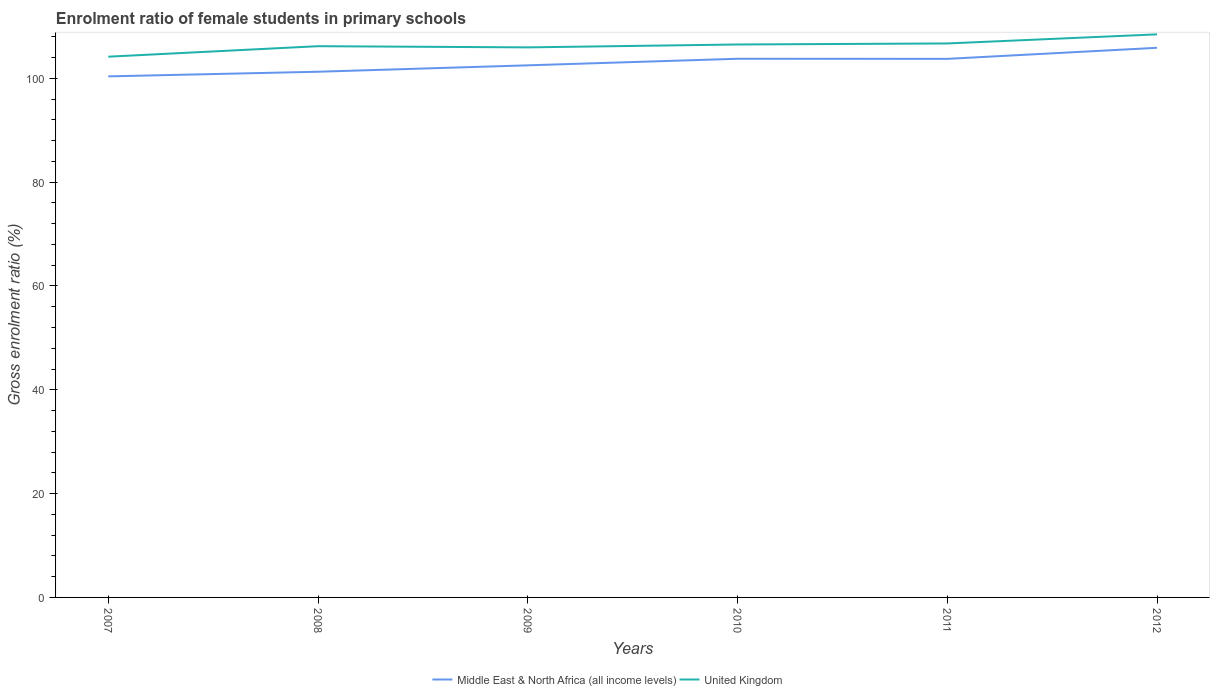How many different coloured lines are there?
Provide a succinct answer. 2. Does the line corresponding to United Kingdom intersect with the line corresponding to Middle East & North Africa (all income levels)?
Give a very brief answer. No. Is the number of lines equal to the number of legend labels?
Offer a terse response. Yes. Across all years, what is the maximum enrolment ratio of female students in primary schools in United Kingdom?
Offer a terse response. 104.18. In which year was the enrolment ratio of female students in primary schools in Middle East & North Africa (all income levels) maximum?
Make the answer very short. 2007. What is the total enrolment ratio of female students in primary schools in United Kingdom in the graph?
Your response must be concise. -2.28. What is the difference between the highest and the second highest enrolment ratio of female students in primary schools in United Kingdom?
Provide a short and direct response. 4.3. Is the enrolment ratio of female students in primary schools in United Kingdom strictly greater than the enrolment ratio of female students in primary schools in Middle East & North Africa (all income levels) over the years?
Your answer should be compact. No. How many years are there in the graph?
Your answer should be very brief. 6. What is the difference between two consecutive major ticks on the Y-axis?
Offer a very short reply. 20. Are the values on the major ticks of Y-axis written in scientific E-notation?
Offer a terse response. No. Does the graph contain any zero values?
Give a very brief answer. No. How are the legend labels stacked?
Your answer should be compact. Horizontal. What is the title of the graph?
Provide a short and direct response. Enrolment ratio of female students in primary schools. Does "Zimbabwe" appear as one of the legend labels in the graph?
Your answer should be very brief. No. What is the Gross enrolment ratio (%) in Middle East & North Africa (all income levels) in 2007?
Your answer should be very brief. 100.38. What is the Gross enrolment ratio (%) of United Kingdom in 2007?
Provide a succinct answer. 104.18. What is the Gross enrolment ratio (%) of Middle East & North Africa (all income levels) in 2008?
Offer a terse response. 101.28. What is the Gross enrolment ratio (%) of United Kingdom in 2008?
Make the answer very short. 106.2. What is the Gross enrolment ratio (%) in Middle East & North Africa (all income levels) in 2009?
Offer a terse response. 102.51. What is the Gross enrolment ratio (%) of United Kingdom in 2009?
Give a very brief answer. 105.97. What is the Gross enrolment ratio (%) in Middle East & North Africa (all income levels) in 2010?
Keep it short and to the point. 103.78. What is the Gross enrolment ratio (%) in United Kingdom in 2010?
Give a very brief answer. 106.53. What is the Gross enrolment ratio (%) in Middle East & North Africa (all income levels) in 2011?
Your response must be concise. 103.76. What is the Gross enrolment ratio (%) of United Kingdom in 2011?
Make the answer very short. 106.72. What is the Gross enrolment ratio (%) in Middle East & North Africa (all income levels) in 2012?
Make the answer very short. 105.89. What is the Gross enrolment ratio (%) of United Kingdom in 2012?
Offer a terse response. 108.48. Across all years, what is the maximum Gross enrolment ratio (%) of Middle East & North Africa (all income levels)?
Your answer should be compact. 105.89. Across all years, what is the maximum Gross enrolment ratio (%) in United Kingdom?
Make the answer very short. 108.48. Across all years, what is the minimum Gross enrolment ratio (%) of Middle East & North Africa (all income levels)?
Ensure brevity in your answer.  100.38. Across all years, what is the minimum Gross enrolment ratio (%) in United Kingdom?
Provide a succinct answer. 104.18. What is the total Gross enrolment ratio (%) in Middle East & North Africa (all income levels) in the graph?
Offer a very short reply. 617.59. What is the total Gross enrolment ratio (%) in United Kingdom in the graph?
Give a very brief answer. 638.07. What is the difference between the Gross enrolment ratio (%) in Middle East & North Africa (all income levels) in 2007 and that in 2008?
Provide a short and direct response. -0.89. What is the difference between the Gross enrolment ratio (%) of United Kingdom in 2007 and that in 2008?
Your answer should be compact. -2.02. What is the difference between the Gross enrolment ratio (%) in Middle East & North Africa (all income levels) in 2007 and that in 2009?
Offer a very short reply. -2.13. What is the difference between the Gross enrolment ratio (%) in United Kingdom in 2007 and that in 2009?
Your response must be concise. -1.79. What is the difference between the Gross enrolment ratio (%) of Middle East & North Africa (all income levels) in 2007 and that in 2010?
Offer a very short reply. -3.39. What is the difference between the Gross enrolment ratio (%) of United Kingdom in 2007 and that in 2010?
Give a very brief answer. -2.35. What is the difference between the Gross enrolment ratio (%) of Middle East & North Africa (all income levels) in 2007 and that in 2011?
Offer a terse response. -3.38. What is the difference between the Gross enrolment ratio (%) in United Kingdom in 2007 and that in 2011?
Offer a very short reply. -2.55. What is the difference between the Gross enrolment ratio (%) of Middle East & North Africa (all income levels) in 2007 and that in 2012?
Keep it short and to the point. -5.51. What is the difference between the Gross enrolment ratio (%) of United Kingdom in 2007 and that in 2012?
Make the answer very short. -4.3. What is the difference between the Gross enrolment ratio (%) of Middle East & North Africa (all income levels) in 2008 and that in 2009?
Provide a succinct answer. -1.23. What is the difference between the Gross enrolment ratio (%) in United Kingdom in 2008 and that in 2009?
Make the answer very short. 0.23. What is the difference between the Gross enrolment ratio (%) of Middle East & North Africa (all income levels) in 2008 and that in 2010?
Offer a very short reply. -2.5. What is the difference between the Gross enrolment ratio (%) of United Kingdom in 2008 and that in 2010?
Your response must be concise. -0.33. What is the difference between the Gross enrolment ratio (%) of Middle East & North Africa (all income levels) in 2008 and that in 2011?
Provide a succinct answer. -2.48. What is the difference between the Gross enrolment ratio (%) in United Kingdom in 2008 and that in 2011?
Provide a short and direct response. -0.53. What is the difference between the Gross enrolment ratio (%) of Middle East & North Africa (all income levels) in 2008 and that in 2012?
Make the answer very short. -4.61. What is the difference between the Gross enrolment ratio (%) in United Kingdom in 2008 and that in 2012?
Your answer should be very brief. -2.28. What is the difference between the Gross enrolment ratio (%) of Middle East & North Africa (all income levels) in 2009 and that in 2010?
Offer a very short reply. -1.27. What is the difference between the Gross enrolment ratio (%) of United Kingdom in 2009 and that in 2010?
Provide a short and direct response. -0.56. What is the difference between the Gross enrolment ratio (%) in Middle East & North Africa (all income levels) in 2009 and that in 2011?
Keep it short and to the point. -1.25. What is the difference between the Gross enrolment ratio (%) of United Kingdom in 2009 and that in 2011?
Offer a terse response. -0.75. What is the difference between the Gross enrolment ratio (%) of Middle East & North Africa (all income levels) in 2009 and that in 2012?
Give a very brief answer. -3.38. What is the difference between the Gross enrolment ratio (%) in United Kingdom in 2009 and that in 2012?
Offer a very short reply. -2.51. What is the difference between the Gross enrolment ratio (%) in Middle East & North Africa (all income levels) in 2010 and that in 2011?
Provide a succinct answer. 0.02. What is the difference between the Gross enrolment ratio (%) of United Kingdom in 2010 and that in 2011?
Offer a terse response. -0.2. What is the difference between the Gross enrolment ratio (%) of Middle East & North Africa (all income levels) in 2010 and that in 2012?
Give a very brief answer. -2.11. What is the difference between the Gross enrolment ratio (%) of United Kingdom in 2010 and that in 2012?
Keep it short and to the point. -1.95. What is the difference between the Gross enrolment ratio (%) in Middle East & North Africa (all income levels) in 2011 and that in 2012?
Your answer should be very brief. -2.13. What is the difference between the Gross enrolment ratio (%) of United Kingdom in 2011 and that in 2012?
Your answer should be very brief. -1.75. What is the difference between the Gross enrolment ratio (%) of Middle East & North Africa (all income levels) in 2007 and the Gross enrolment ratio (%) of United Kingdom in 2008?
Offer a terse response. -5.82. What is the difference between the Gross enrolment ratio (%) in Middle East & North Africa (all income levels) in 2007 and the Gross enrolment ratio (%) in United Kingdom in 2009?
Ensure brevity in your answer.  -5.59. What is the difference between the Gross enrolment ratio (%) of Middle East & North Africa (all income levels) in 2007 and the Gross enrolment ratio (%) of United Kingdom in 2010?
Keep it short and to the point. -6.15. What is the difference between the Gross enrolment ratio (%) of Middle East & North Africa (all income levels) in 2007 and the Gross enrolment ratio (%) of United Kingdom in 2011?
Give a very brief answer. -6.34. What is the difference between the Gross enrolment ratio (%) of Middle East & North Africa (all income levels) in 2007 and the Gross enrolment ratio (%) of United Kingdom in 2012?
Give a very brief answer. -8.1. What is the difference between the Gross enrolment ratio (%) in Middle East & North Africa (all income levels) in 2008 and the Gross enrolment ratio (%) in United Kingdom in 2009?
Provide a short and direct response. -4.69. What is the difference between the Gross enrolment ratio (%) in Middle East & North Africa (all income levels) in 2008 and the Gross enrolment ratio (%) in United Kingdom in 2010?
Offer a terse response. -5.25. What is the difference between the Gross enrolment ratio (%) in Middle East & North Africa (all income levels) in 2008 and the Gross enrolment ratio (%) in United Kingdom in 2011?
Offer a very short reply. -5.45. What is the difference between the Gross enrolment ratio (%) of Middle East & North Africa (all income levels) in 2008 and the Gross enrolment ratio (%) of United Kingdom in 2012?
Your answer should be very brief. -7.2. What is the difference between the Gross enrolment ratio (%) of Middle East & North Africa (all income levels) in 2009 and the Gross enrolment ratio (%) of United Kingdom in 2010?
Keep it short and to the point. -4.02. What is the difference between the Gross enrolment ratio (%) of Middle East & North Africa (all income levels) in 2009 and the Gross enrolment ratio (%) of United Kingdom in 2011?
Your response must be concise. -4.21. What is the difference between the Gross enrolment ratio (%) in Middle East & North Africa (all income levels) in 2009 and the Gross enrolment ratio (%) in United Kingdom in 2012?
Your answer should be very brief. -5.97. What is the difference between the Gross enrolment ratio (%) in Middle East & North Africa (all income levels) in 2010 and the Gross enrolment ratio (%) in United Kingdom in 2011?
Offer a very short reply. -2.95. What is the difference between the Gross enrolment ratio (%) in Middle East & North Africa (all income levels) in 2010 and the Gross enrolment ratio (%) in United Kingdom in 2012?
Give a very brief answer. -4.7. What is the difference between the Gross enrolment ratio (%) in Middle East & North Africa (all income levels) in 2011 and the Gross enrolment ratio (%) in United Kingdom in 2012?
Your answer should be very brief. -4.72. What is the average Gross enrolment ratio (%) in Middle East & North Africa (all income levels) per year?
Offer a very short reply. 102.93. What is the average Gross enrolment ratio (%) in United Kingdom per year?
Provide a short and direct response. 106.35. In the year 2007, what is the difference between the Gross enrolment ratio (%) of Middle East & North Africa (all income levels) and Gross enrolment ratio (%) of United Kingdom?
Provide a succinct answer. -3.79. In the year 2008, what is the difference between the Gross enrolment ratio (%) in Middle East & North Africa (all income levels) and Gross enrolment ratio (%) in United Kingdom?
Provide a short and direct response. -4.92. In the year 2009, what is the difference between the Gross enrolment ratio (%) in Middle East & North Africa (all income levels) and Gross enrolment ratio (%) in United Kingdom?
Keep it short and to the point. -3.46. In the year 2010, what is the difference between the Gross enrolment ratio (%) in Middle East & North Africa (all income levels) and Gross enrolment ratio (%) in United Kingdom?
Your answer should be compact. -2.75. In the year 2011, what is the difference between the Gross enrolment ratio (%) in Middle East & North Africa (all income levels) and Gross enrolment ratio (%) in United Kingdom?
Your response must be concise. -2.97. In the year 2012, what is the difference between the Gross enrolment ratio (%) in Middle East & North Africa (all income levels) and Gross enrolment ratio (%) in United Kingdom?
Provide a short and direct response. -2.59. What is the ratio of the Gross enrolment ratio (%) in Middle East & North Africa (all income levels) in 2007 to that in 2008?
Ensure brevity in your answer.  0.99. What is the ratio of the Gross enrolment ratio (%) in Middle East & North Africa (all income levels) in 2007 to that in 2009?
Ensure brevity in your answer.  0.98. What is the ratio of the Gross enrolment ratio (%) in United Kingdom in 2007 to that in 2009?
Offer a terse response. 0.98. What is the ratio of the Gross enrolment ratio (%) of Middle East & North Africa (all income levels) in 2007 to that in 2010?
Provide a short and direct response. 0.97. What is the ratio of the Gross enrolment ratio (%) in United Kingdom in 2007 to that in 2010?
Offer a terse response. 0.98. What is the ratio of the Gross enrolment ratio (%) of Middle East & North Africa (all income levels) in 2007 to that in 2011?
Your answer should be compact. 0.97. What is the ratio of the Gross enrolment ratio (%) of United Kingdom in 2007 to that in 2011?
Provide a succinct answer. 0.98. What is the ratio of the Gross enrolment ratio (%) in Middle East & North Africa (all income levels) in 2007 to that in 2012?
Keep it short and to the point. 0.95. What is the ratio of the Gross enrolment ratio (%) in United Kingdom in 2007 to that in 2012?
Offer a terse response. 0.96. What is the ratio of the Gross enrolment ratio (%) in Middle East & North Africa (all income levels) in 2008 to that in 2009?
Your response must be concise. 0.99. What is the ratio of the Gross enrolment ratio (%) of United Kingdom in 2008 to that in 2009?
Ensure brevity in your answer.  1. What is the ratio of the Gross enrolment ratio (%) in Middle East & North Africa (all income levels) in 2008 to that in 2010?
Make the answer very short. 0.98. What is the ratio of the Gross enrolment ratio (%) of United Kingdom in 2008 to that in 2010?
Offer a very short reply. 1. What is the ratio of the Gross enrolment ratio (%) of Middle East & North Africa (all income levels) in 2008 to that in 2011?
Give a very brief answer. 0.98. What is the ratio of the Gross enrolment ratio (%) of Middle East & North Africa (all income levels) in 2008 to that in 2012?
Provide a short and direct response. 0.96. What is the ratio of the Gross enrolment ratio (%) of United Kingdom in 2008 to that in 2012?
Provide a succinct answer. 0.98. What is the ratio of the Gross enrolment ratio (%) of Middle East & North Africa (all income levels) in 2009 to that in 2010?
Provide a short and direct response. 0.99. What is the ratio of the Gross enrolment ratio (%) of United Kingdom in 2009 to that in 2010?
Your answer should be very brief. 0.99. What is the ratio of the Gross enrolment ratio (%) of Middle East & North Africa (all income levels) in 2009 to that in 2011?
Your answer should be compact. 0.99. What is the ratio of the Gross enrolment ratio (%) in United Kingdom in 2009 to that in 2011?
Keep it short and to the point. 0.99. What is the ratio of the Gross enrolment ratio (%) of Middle East & North Africa (all income levels) in 2009 to that in 2012?
Your response must be concise. 0.97. What is the ratio of the Gross enrolment ratio (%) of United Kingdom in 2009 to that in 2012?
Your answer should be very brief. 0.98. What is the ratio of the Gross enrolment ratio (%) in United Kingdom in 2010 to that in 2011?
Give a very brief answer. 1. What is the ratio of the Gross enrolment ratio (%) in Middle East & North Africa (all income levels) in 2010 to that in 2012?
Keep it short and to the point. 0.98. What is the ratio of the Gross enrolment ratio (%) of United Kingdom in 2010 to that in 2012?
Provide a succinct answer. 0.98. What is the ratio of the Gross enrolment ratio (%) in Middle East & North Africa (all income levels) in 2011 to that in 2012?
Your answer should be compact. 0.98. What is the ratio of the Gross enrolment ratio (%) in United Kingdom in 2011 to that in 2012?
Your response must be concise. 0.98. What is the difference between the highest and the second highest Gross enrolment ratio (%) of Middle East & North Africa (all income levels)?
Ensure brevity in your answer.  2.11. What is the difference between the highest and the second highest Gross enrolment ratio (%) in United Kingdom?
Give a very brief answer. 1.75. What is the difference between the highest and the lowest Gross enrolment ratio (%) of Middle East & North Africa (all income levels)?
Make the answer very short. 5.51. What is the difference between the highest and the lowest Gross enrolment ratio (%) in United Kingdom?
Provide a succinct answer. 4.3. 